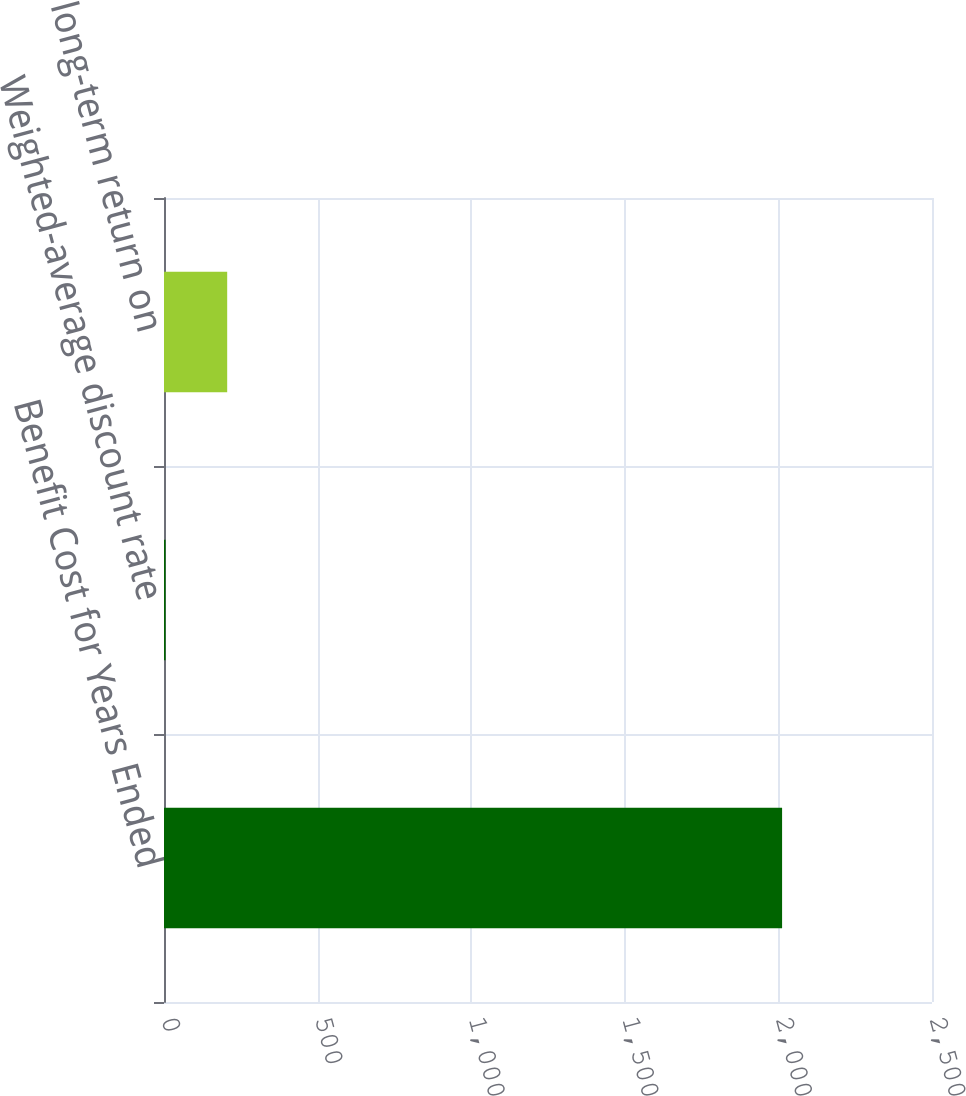<chart> <loc_0><loc_0><loc_500><loc_500><bar_chart><fcel>Benefit Cost for Years Ended<fcel>Weighted-average discount rate<fcel>Expected long-term return on<nl><fcel>2012<fcel>5<fcel>205.7<nl></chart> 